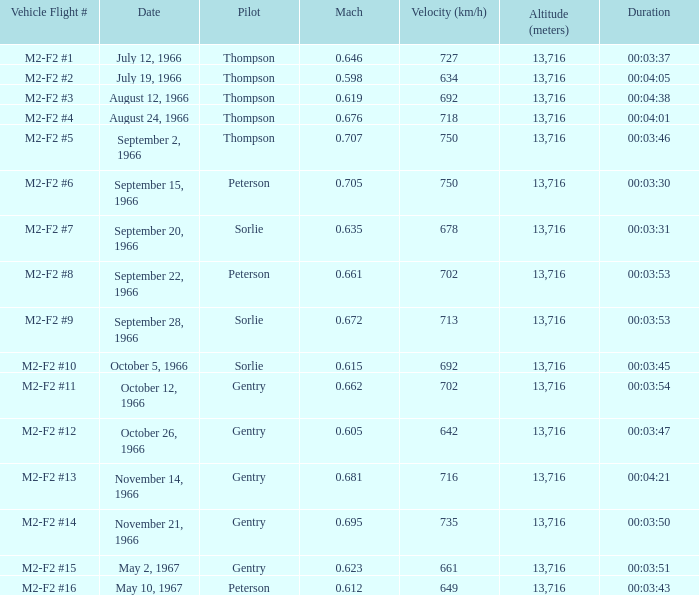What is the mach number for vehicle flight # m2-f2 #8 when the altitude is above 13,716 meters? None. 